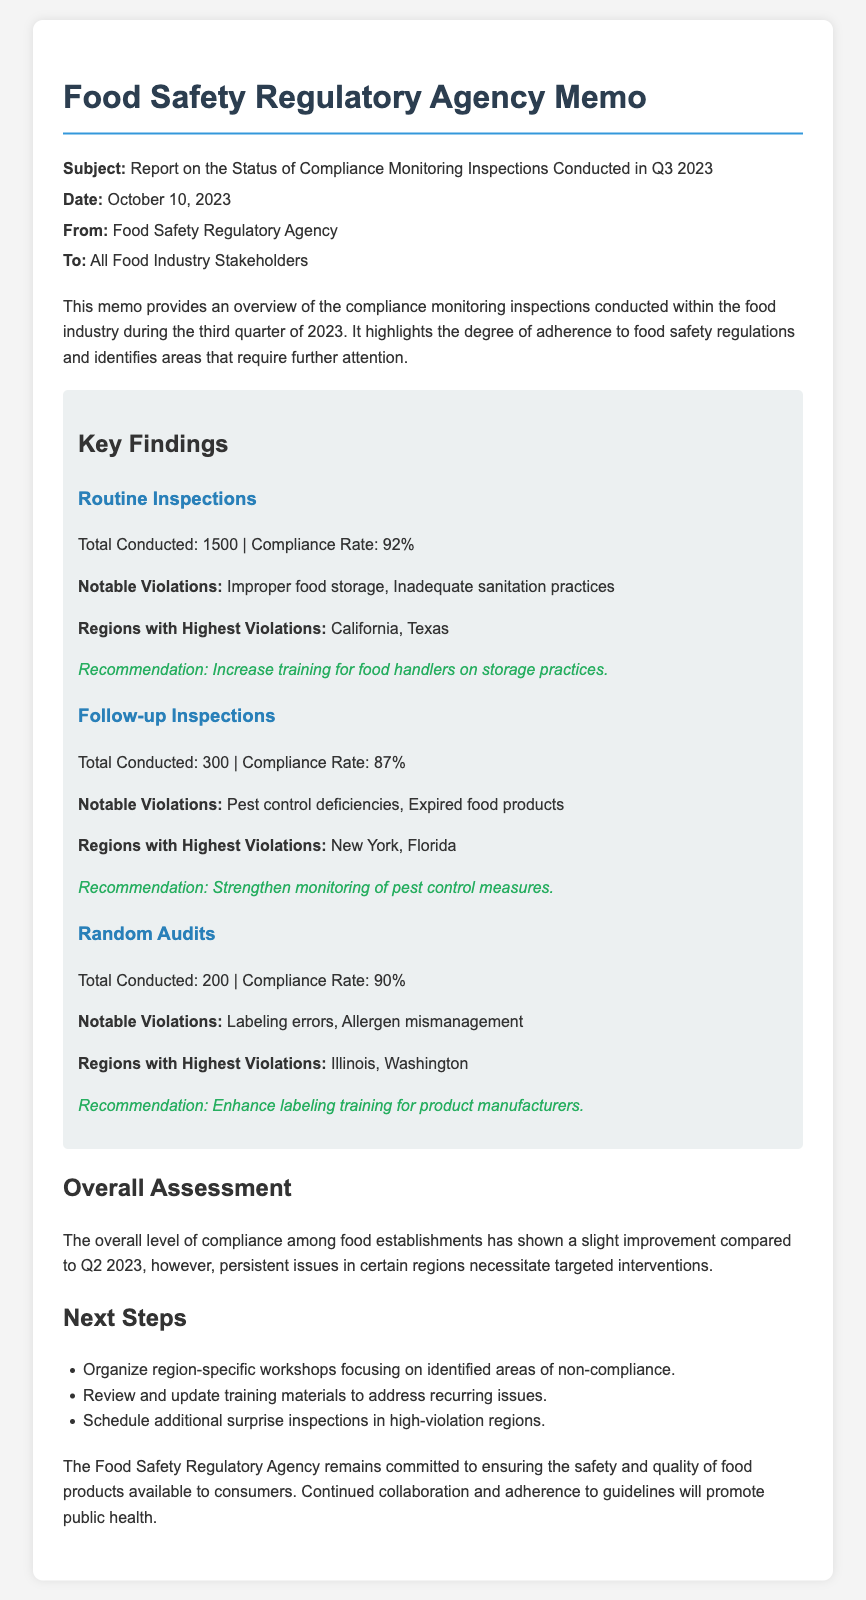What is the total number of routine inspections conducted? The document states that a total of 1500 routine inspections were conducted.
Answer: 1500 What was the compliance rate for follow-up inspections? According to the document, the compliance rate for follow-up inspections was 87%.
Answer: 87% What are notable violations for random audits? The memo lists labeling errors and allergen mismanagement as notable violations for random audits.
Answer: Labeling errors, Allergen mismanagement Which regions had the highest violations in routine inspections? The document indicates California and Texas as the regions with the highest violations in routine inspections.
Answer: California, Texas What is the recommendation for follow-up inspections? The memo recommends strengthening monitoring of pest control measures based on the findings of follow-up inspections.
Answer: Strengthen monitoring of pest control measures What is the overall assessment of compliance in Q3 2023? The overall assessment indicates a slight improvement in compliance compared to Q2 2023.
Answer: Slight improvement How many random audits were conducted? The document states that there were 200 random audits conducted in Q3 2023.
Answer: 200 What is the date of the memo? The date of the memo is specified as October 10, 2023.
Answer: October 10, 2023 What are the next steps proposed in the document? The document outlines organizing region-specific workshops, reviewing training materials, and scheduling surprise inspections as next steps.
Answer: Organize region-specific workshops, review training materials, schedule surprise inspections 